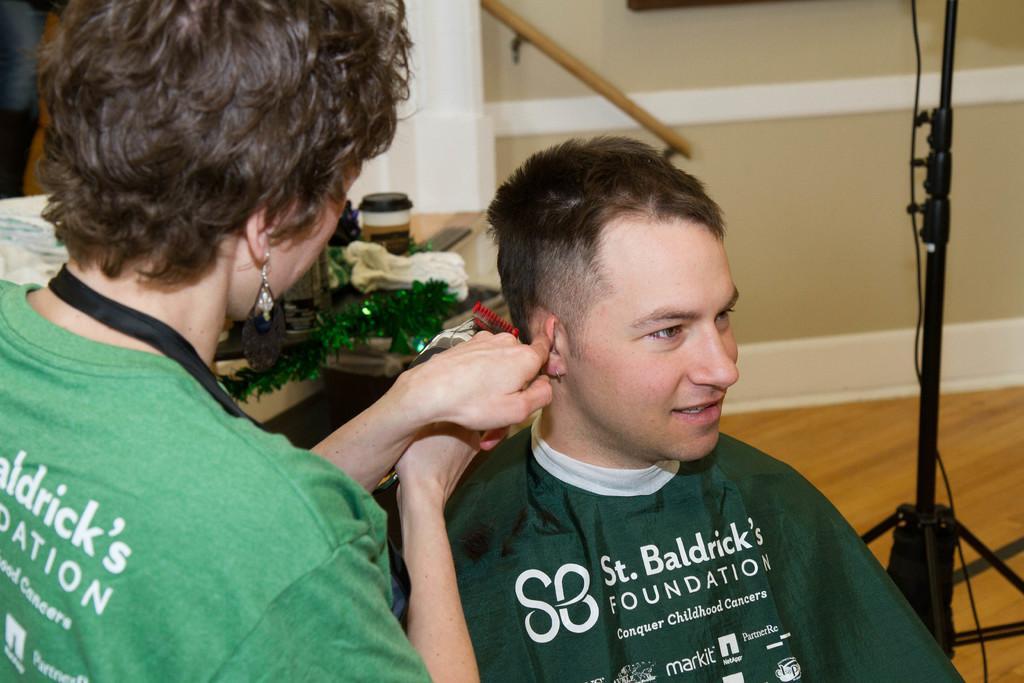Can you describe this image briefly? In this picture I can see a woman cutting hair of a man with the help of a trimmer and I can see a cup and few items on the table in the back and I can see a stand on the right side of the picture. 